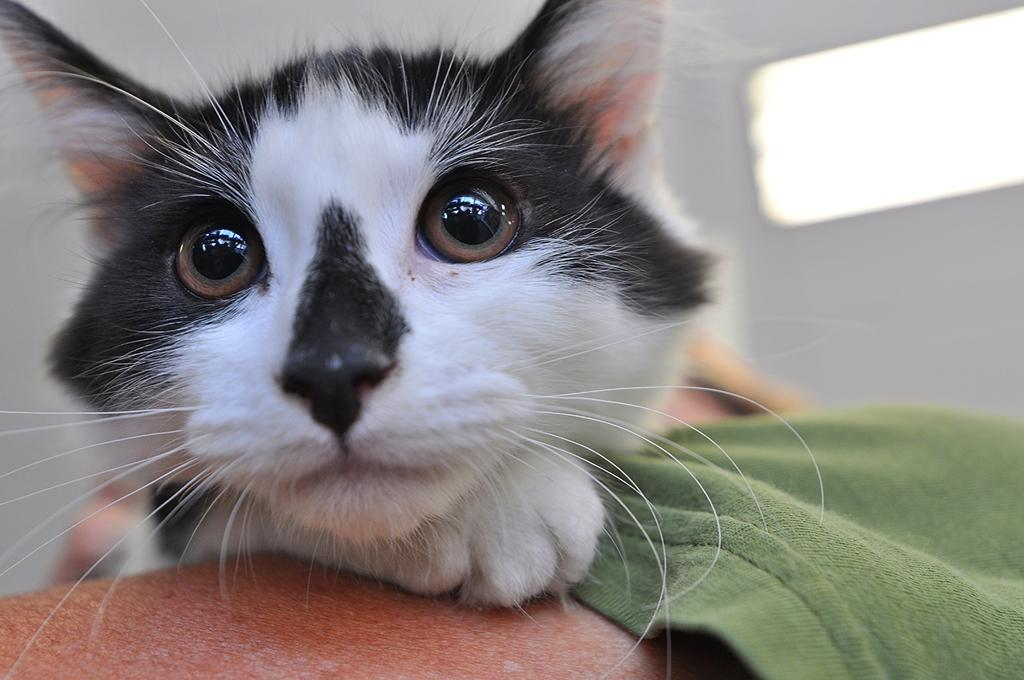What type of animal is in the image? There is a cat in the image. Can you describe the color pattern of the cat? The cat has white and black colors. What part of a person can be seen in the image? The hand of a person is visible in the image. What is the person wearing on their upper body? The person is wearing a green T-shirt. What is in the background of the image? There is a wall in the background of the image. How many spiders are crawling on the wall in the image? There are no spiders visible in the image; it only features a cat, a person's hand, and a wall. What type of glue is being used to attach the range to the wall in the image? There is no range or glue present in the image; it only features a cat, a person's hand, and a wall. 